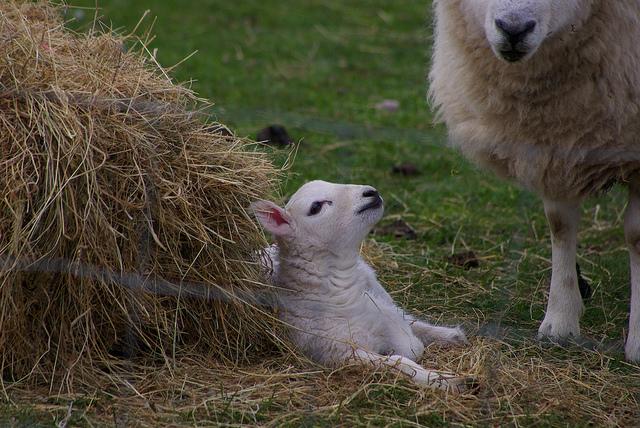How many baby animals are in this picture?
Write a very short answer. 1. How many animals are there?
Concise answer only. 2. How many feet are visible in this picture?
Give a very brief answer. 4. Is the animal in the picture laying down?
Answer briefly. Yes. Was the sheep recently shorn?
Write a very short answer. No. How many eyes can be seen?
Answer briefly. 1. Why is the smaller animal laying in dirt?
Keep it brief. Resting. Are the animals males?
Answer briefly. No. What is right in front of second sheep's feet?
Concise answer only. Hay. What is the baby sheep looking at?
Give a very brief answer. Mom. What is the hay for?
Short answer required. Eating. What material comes from sheep?
Short answer required. Wool. How old is this sheep?
Keep it brief. 1. Is there a castle in the background?
Quick response, please. No. How many sheep are in the picture?
Answer briefly. 2. Is this a park?
Concise answer only. No. Is the baby sleeping?
Be succinct. No. Is this a sheep or lamb?
Give a very brief answer. Lamb. 